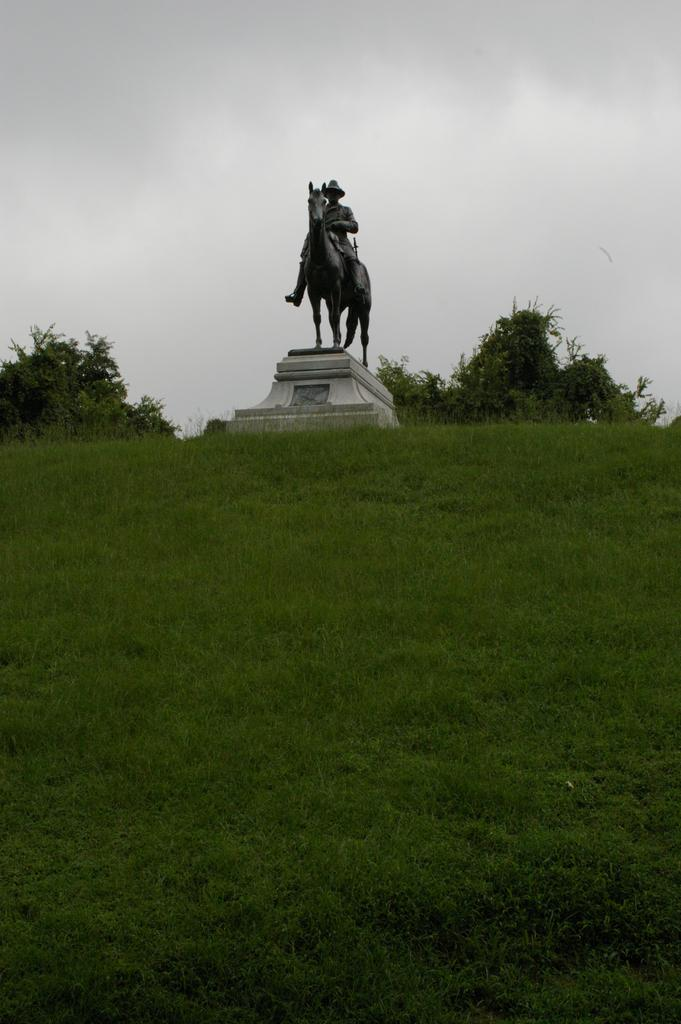What is the main subject in the image? There is a statue in the image. What is the color of the statue? The statue is black in color. What type of vegetation is present in the image? There are trees in the image. What is the color of the grass in the image? The grass in the image is green. What is the color of the sky in the image? The sky appears to be white in color. What type of brush is being used on the statue in the image? There is no brush present in the image. 